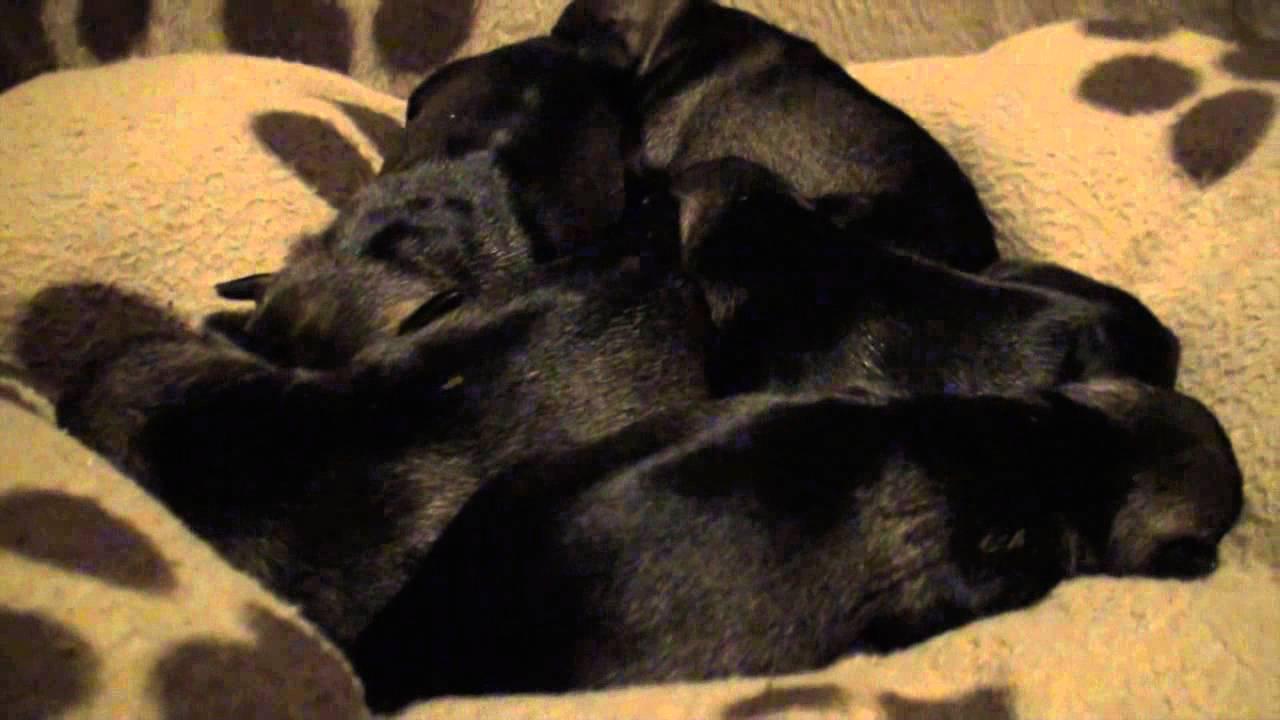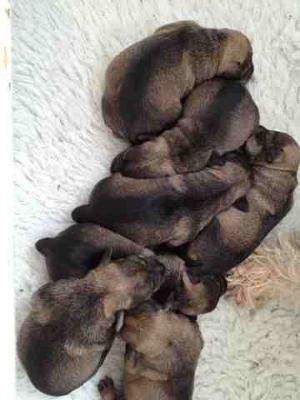The first image is the image on the left, the second image is the image on the right. For the images shown, is this caption "There are four or more puppies sleeping together in each image" true? Answer yes or no. Yes. 